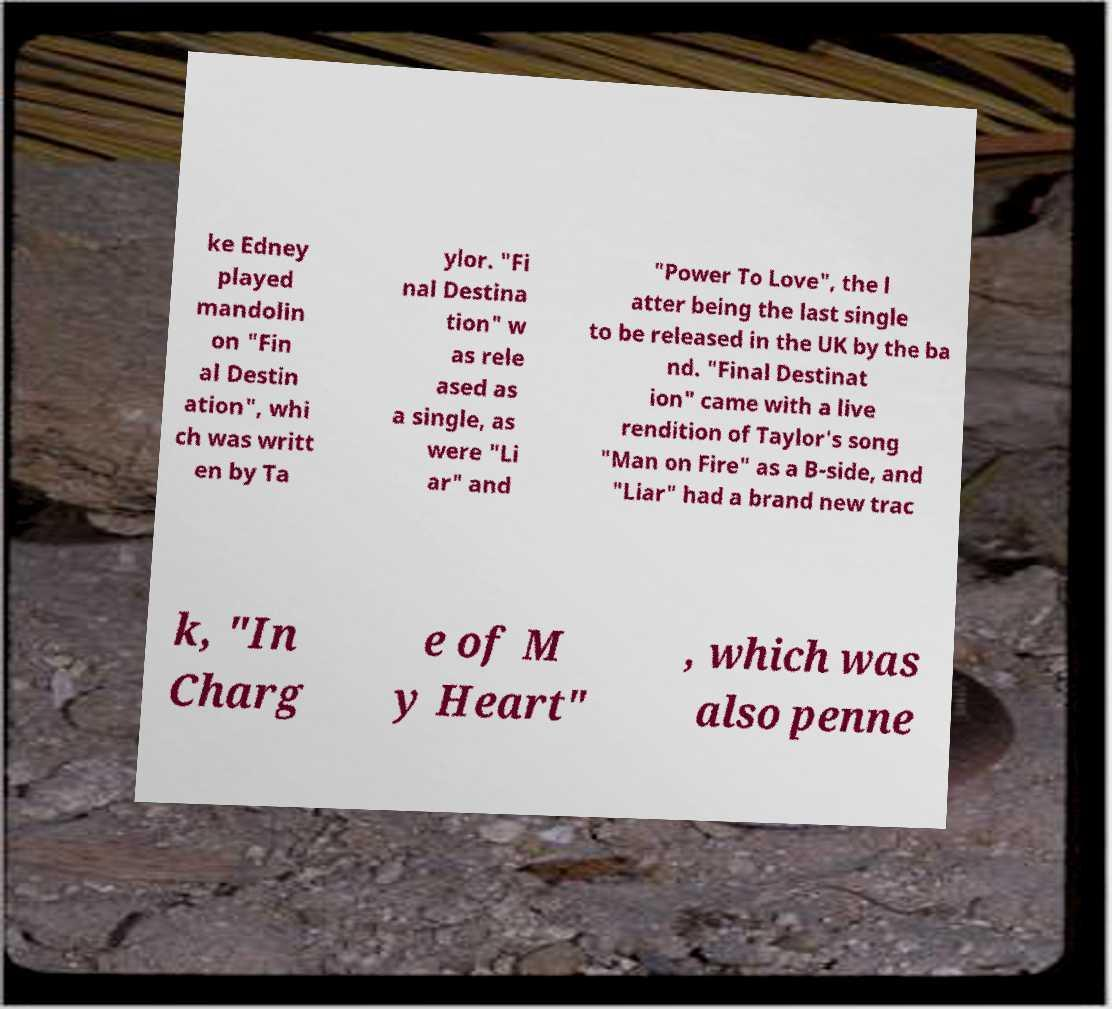Could you extract and type out the text from this image? ke Edney played mandolin on "Fin al Destin ation", whi ch was writt en by Ta ylor. "Fi nal Destina tion" w as rele ased as a single, as were "Li ar" and "Power To Love", the l atter being the last single to be released in the UK by the ba nd. "Final Destinat ion" came with a live rendition of Taylor's song "Man on Fire" as a B-side, and "Liar" had a brand new trac k, "In Charg e of M y Heart" , which was also penne 